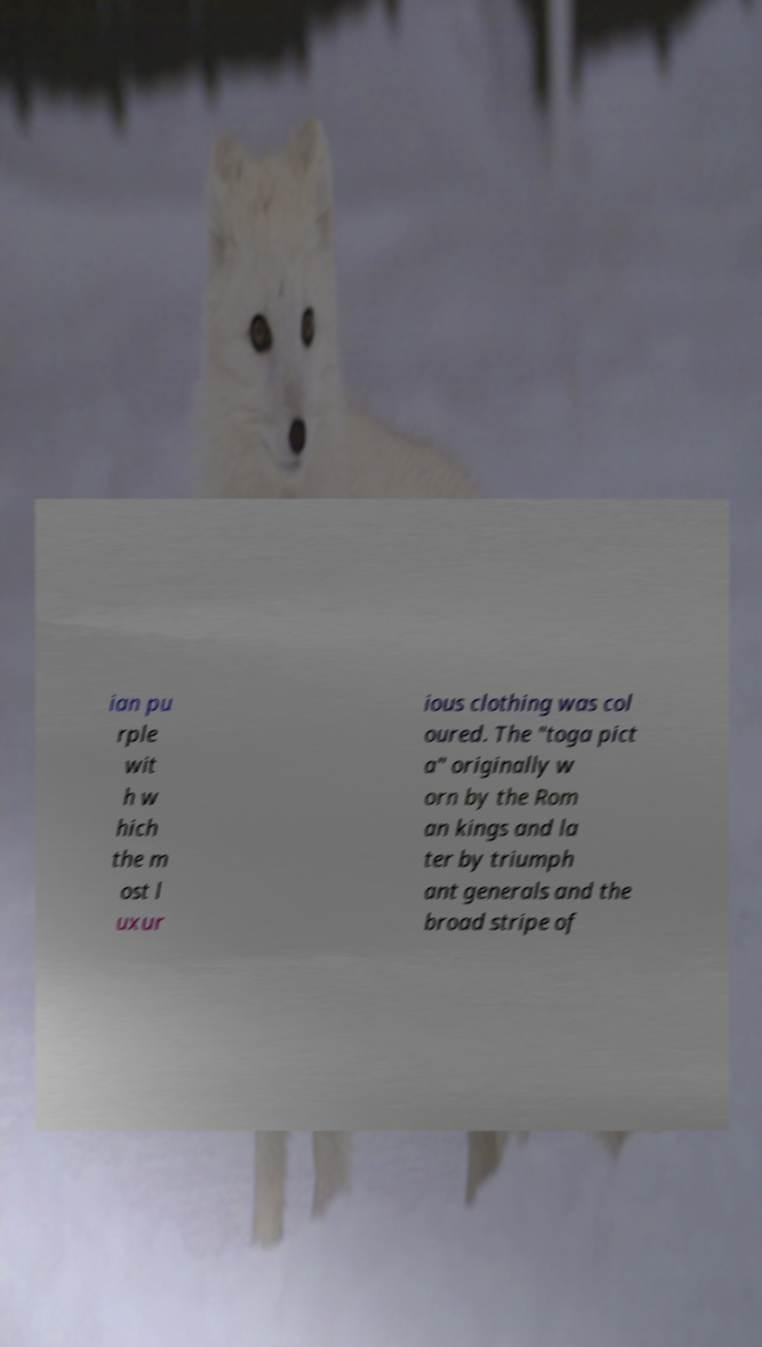For documentation purposes, I need the text within this image transcribed. Could you provide that? ian pu rple wit h w hich the m ost l uxur ious clothing was col oured. The "toga pict a" originally w orn by the Rom an kings and la ter by triumph ant generals and the broad stripe of 